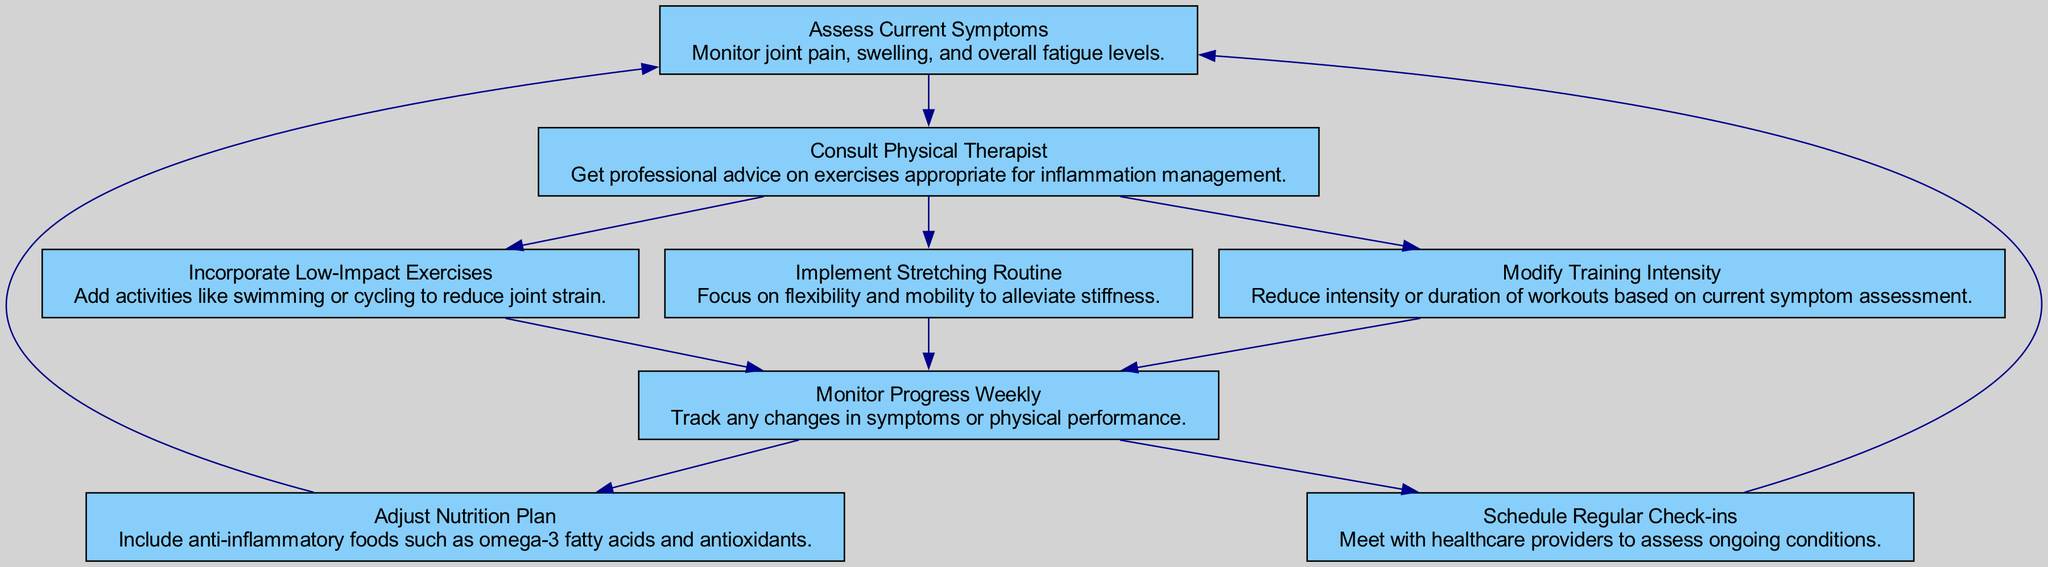What is the first step in the flow chart? The flow chart starts with "Assess Current Symptoms," which is the first node in the sequence.
Answer: Assess Current Symptoms How many nodes are present in the flow chart? By counting each unique step or process in the flow chart, there are a total of eight nodes listed.
Answer: 8 What follows after "Consult Physical Therapist"? The next steps after "Consult Physical Therapist" are "Modify Training Intensity," "Incorporate Low-Impact Exercises," and "Implement Stretching Routine," which are all connected to it.
Answer: Modify Training Intensity, Incorporate Low-Impact Exercises, Implement Stretching Routine What should be done weekly according to the flow chart? The flow chart indicates that "Monitor Progress Weekly" should be conducted weekly to track any changes in symptoms or performance.
Answer: Monitor Progress Weekly How does "Adjust Nutrition Plan" relate to other nodes? "Adjust Nutrition Plan" is connected to "Monitor Progress Weekly," meaning it is supposed to be adjusted based on the weekly symptom assessments.
Answer: After Monitor Progress Weekly What is indicated after assessing "Monitor Progress Weekly"? After monitoring progress weekly, there are two actions indicated: "Adjust Nutrition Plan" and "Schedule Regular Check-ins."
Answer: Adjust Nutrition Plan and Schedule Regular Check-ins What is the purpose of consulting a physical therapist? The purpose of consulting a physical therapist is to get professional advice on exercises that are appropriate for inflammation management.
Answer: Professional advice Which element focuses on alleviating stiffness? "Implement Stretching Routine" is the element that specifically focuses on flexibility and mobility to alleviate stiffness.
Answer: Implement Stretching Routine What type of exercises are recommended to reduce joint strain? "Incorporate Low-Impact Exercises" such as swimming or cycling are recommended to reduce joint strain.
Answer: Incorporate Low-Impact Exercises 